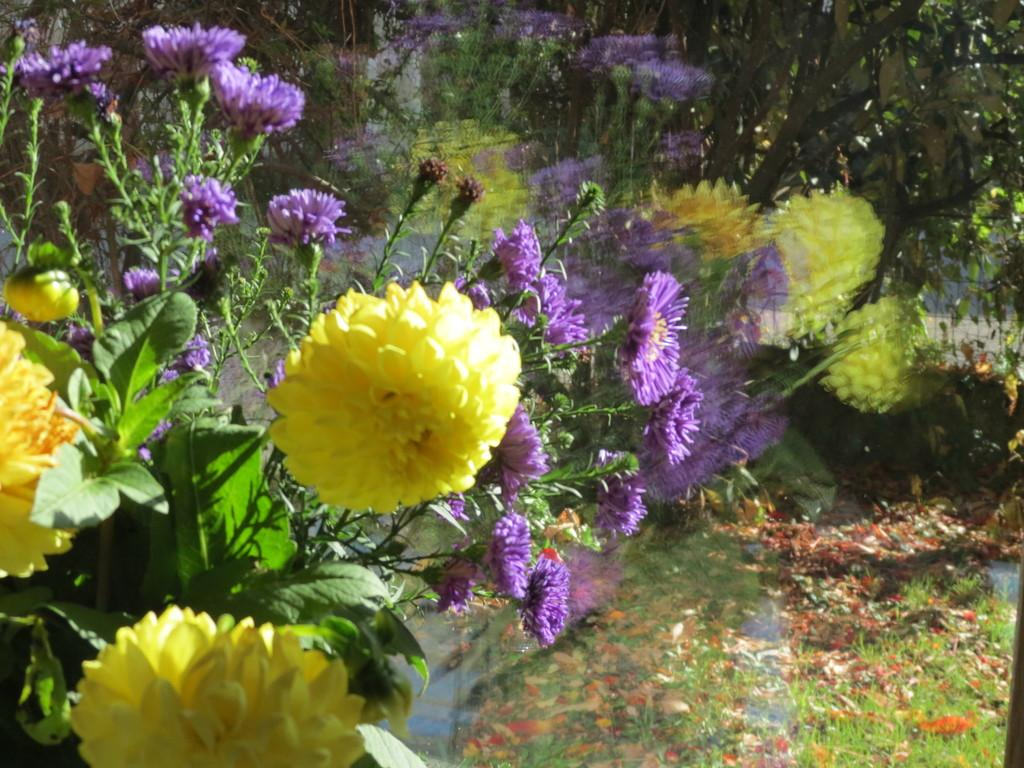What colors are the flowers in the image? There are yellow and purple flowers in the image. What color are the leaves in the image? The leaves in the image are green. What is the background of the image like? The background of the image is blurred. What type of vegetation is visible in the image? Green grass is visible in the image. What type of chair can be seen in the image? There is no chair present in the image. Is there a hospital visible in the image? There is no hospital present in the image. 